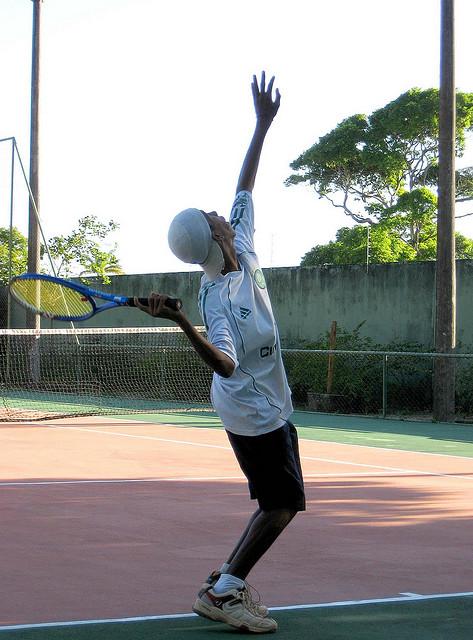Is he reaching downwards?
Quick response, please. No. Is this a layup?
Quick response, please. No. What does the color scheme of the racket remind you of?
Write a very short answer. Tennis ball. 